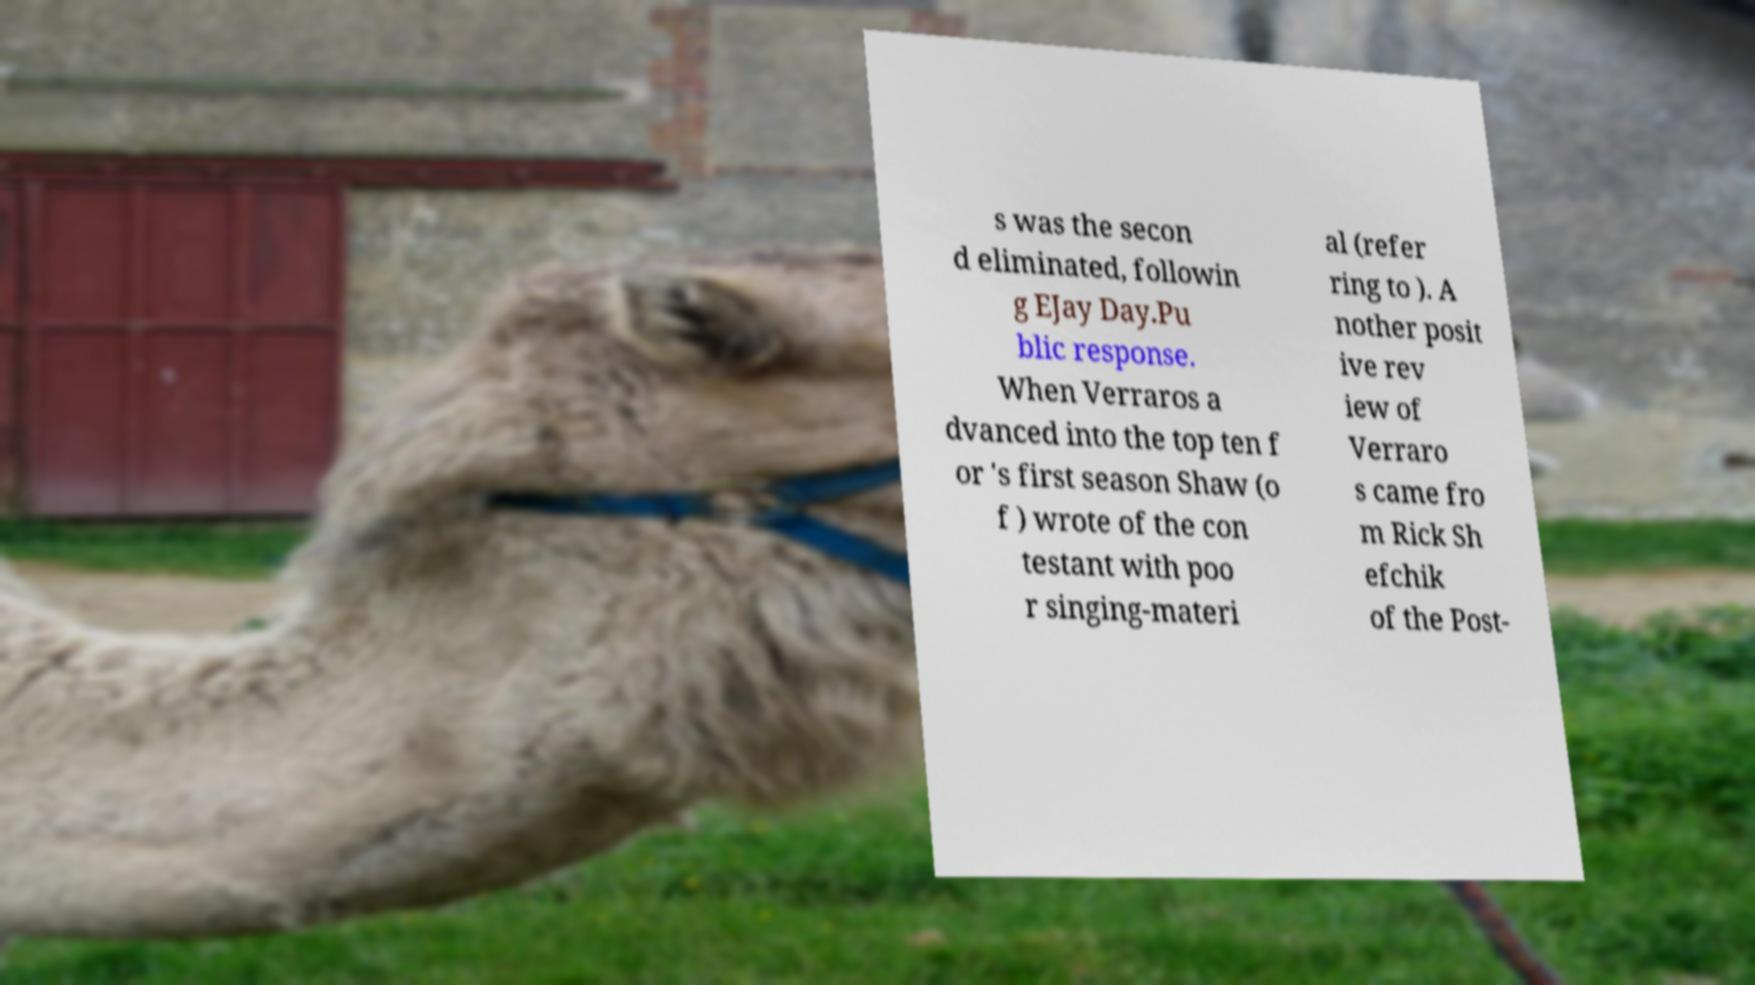I need the written content from this picture converted into text. Can you do that? s was the secon d eliminated, followin g EJay Day.Pu blic response. When Verraros a dvanced into the top ten f or 's first season Shaw (o f ) wrote of the con testant with poo r singing-materi al (refer ring to ). A nother posit ive rev iew of Verraro s came fro m Rick Sh efchik of the Post- 